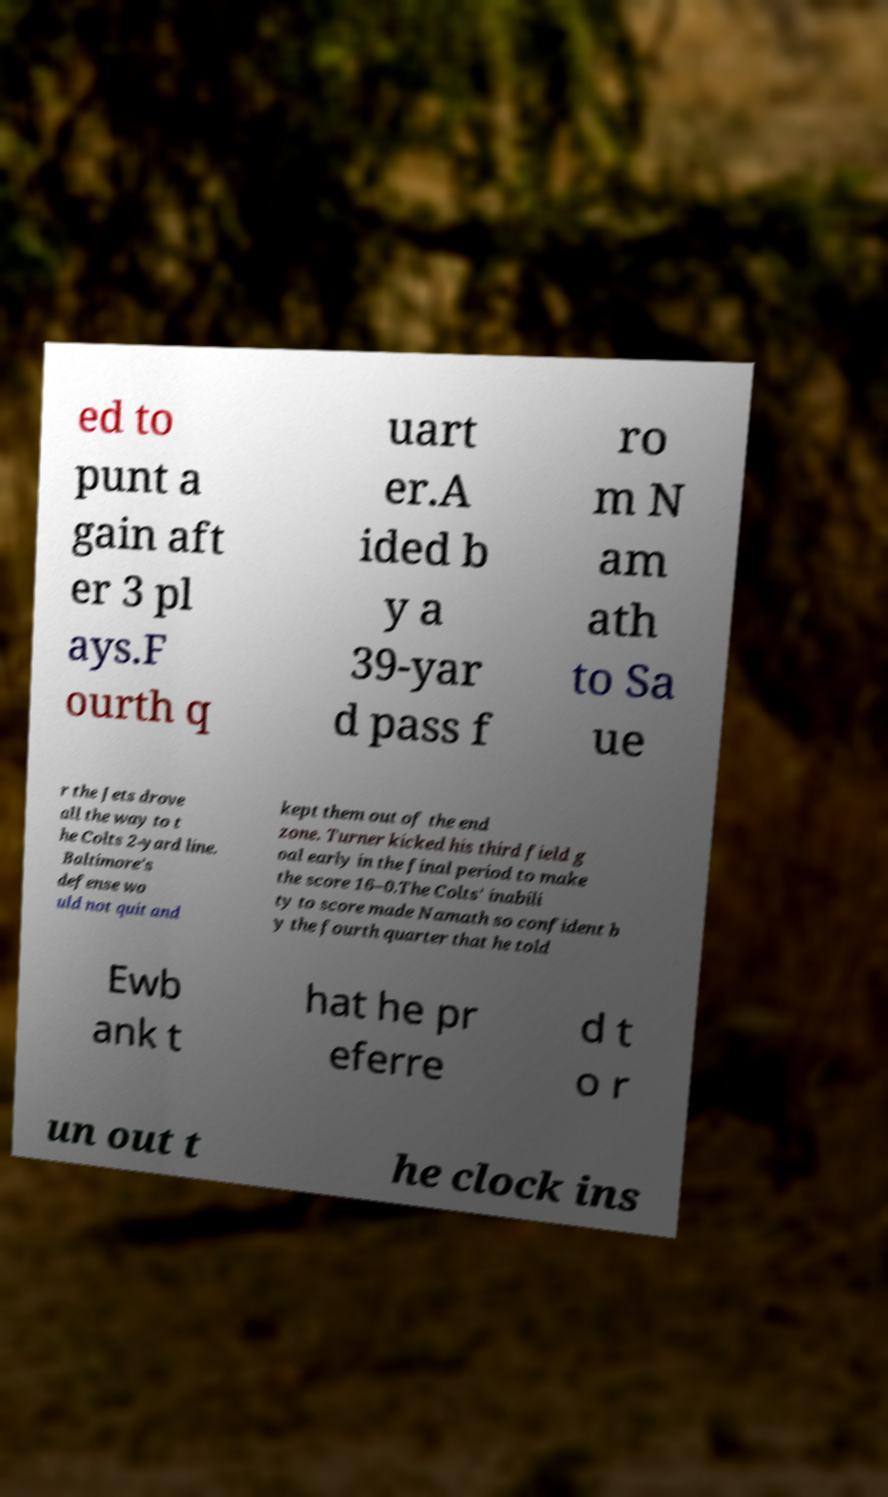There's text embedded in this image that I need extracted. Can you transcribe it verbatim? ed to punt a gain aft er 3 pl ays.F ourth q uart er.A ided b y a 39-yar d pass f ro m N am ath to Sa ue r the Jets drove all the way to t he Colts 2-yard line. Baltimore's defense wo uld not quit and kept them out of the end zone. Turner kicked his third field g oal early in the final period to make the score 16–0.The Colts' inabili ty to score made Namath so confident b y the fourth quarter that he told Ewb ank t hat he pr eferre d t o r un out t he clock ins 